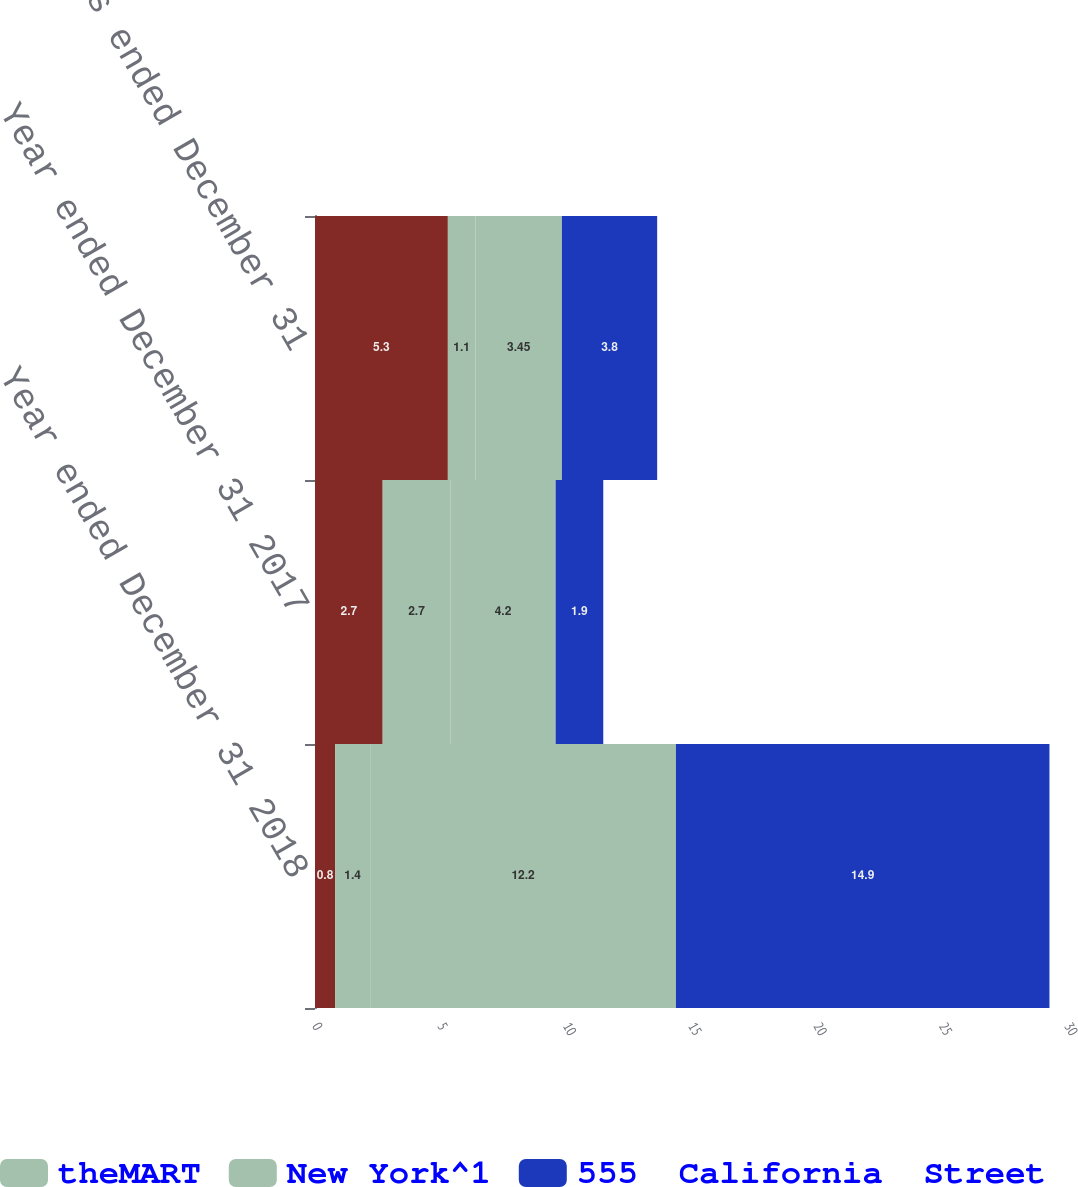Convert chart. <chart><loc_0><loc_0><loc_500><loc_500><stacked_bar_chart><ecel><fcel>Year ended December 31 2018<fcel>Year ended December 31 2017<fcel>Three months ended December 31<nl><fcel>nan<fcel>0.8<fcel>2.7<fcel>5.3<nl><fcel>theMART<fcel>1.4<fcel>2.7<fcel>1.1<nl><fcel>New York^1<fcel>12.2<fcel>4.2<fcel>3.45<nl><fcel>555  California  Street<fcel>14.9<fcel>1.9<fcel>3.8<nl></chart> 